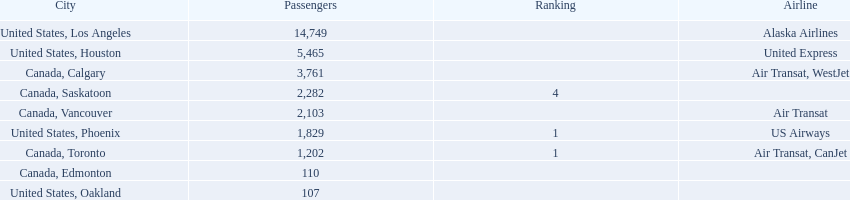What are all the cities? United States, Los Angeles, United States, Houston, Canada, Calgary, Canada, Saskatoon, Canada, Vancouver, United States, Phoenix, Canada, Toronto, Canada, Edmonton, United States, Oakland. How many passengers do they service? 14,749, 5,465, 3,761, 2,282, 2,103, 1,829, 1,202, 110, 107. Which city, when combined with los angeles, totals nearly 19,000? Canada, Calgary. 